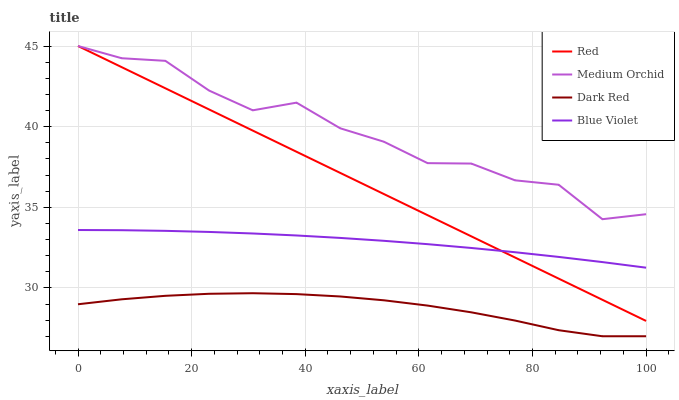Does Dark Red have the minimum area under the curve?
Answer yes or no. Yes. Does Medium Orchid have the maximum area under the curve?
Answer yes or no. Yes. Does Blue Violet have the minimum area under the curve?
Answer yes or no. No. Does Blue Violet have the maximum area under the curve?
Answer yes or no. No. Is Red the smoothest?
Answer yes or no. Yes. Is Medium Orchid the roughest?
Answer yes or no. Yes. Is Blue Violet the smoothest?
Answer yes or no. No. Is Blue Violet the roughest?
Answer yes or no. No. Does Dark Red have the lowest value?
Answer yes or no. Yes. Does Blue Violet have the lowest value?
Answer yes or no. No. Does Red have the highest value?
Answer yes or no. Yes. Does Blue Violet have the highest value?
Answer yes or no. No. Is Blue Violet less than Medium Orchid?
Answer yes or no. Yes. Is Blue Violet greater than Dark Red?
Answer yes or no. Yes. Does Blue Violet intersect Red?
Answer yes or no. Yes. Is Blue Violet less than Red?
Answer yes or no. No. Is Blue Violet greater than Red?
Answer yes or no. No. Does Blue Violet intersect Medium Orchid?
Answer yes or no. No. 